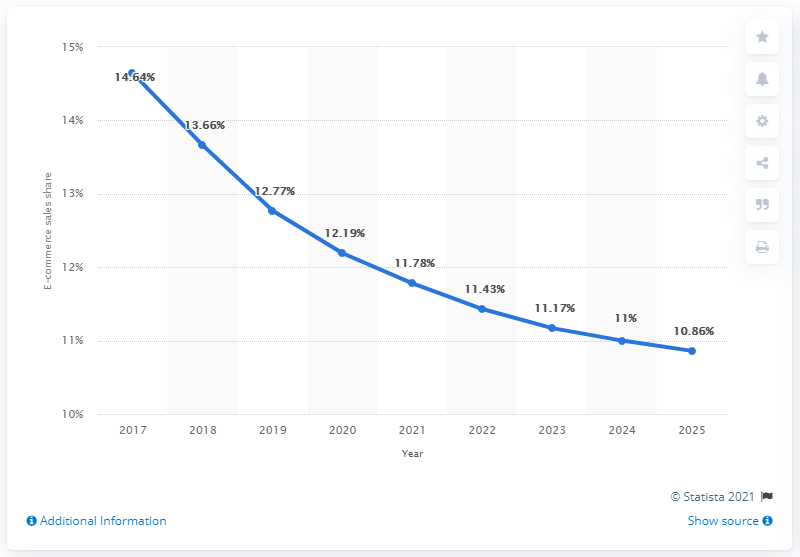Identify some key points in this picture. Sales reached its lowest point in the year 2025. Sales from 2017 to 2020 increased by 2.45. By 2025, e-commerce sales are projected to account for approximately 10.86% of total retail sales. 